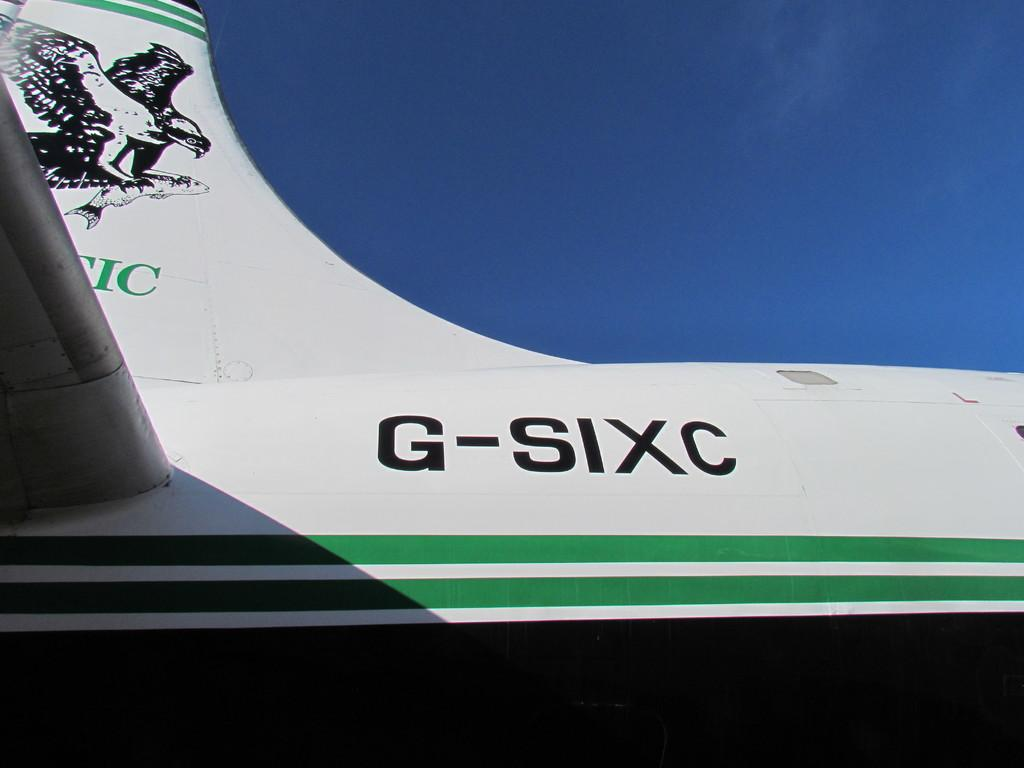Provide a one-sentence caption for the provided image. Eagle is on the wing of the G-SIXC. 